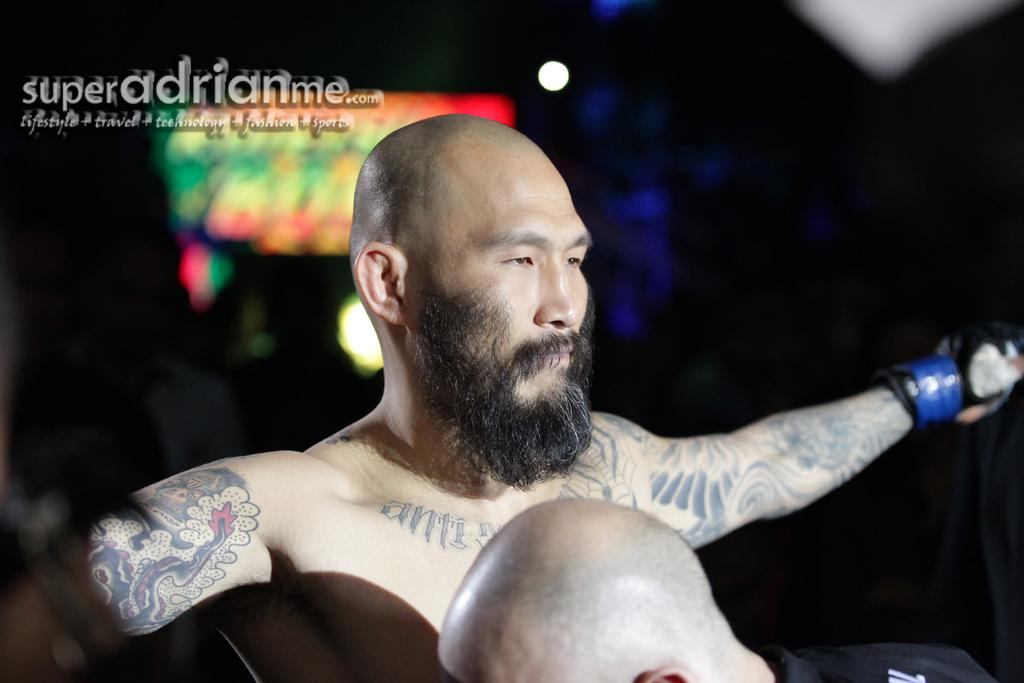How many people are in the image? There are two persons in the image. What can be observed about the background of the image? The background of the image is dark. Is there any text visible in the image? Yes, there is some text in the top left of the image. What type of parent is depicted in the image? There is no parent depicted in the image, as it only features two persons. Can you describe the detail of the father's clothing in the image? There is no father present in the image, so it is not possible to describe the detail of his clothing. 